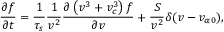<formula> <loc_0><loc_0><loc_500><loc_500>\frac { \partial f } { \partial t } = \frac { 1 } { \tau _ { s } } \frac { 1 } { v ^ { 2 } } \frac { \partial \left ( v ^ { 3 } + v _ { c } ^ { 3 } \right ) f } { \partial v } + \frac { S } { v ^ { 2 } } \delta ( v - v _ { \alpha 0 } ) ,</formula> 